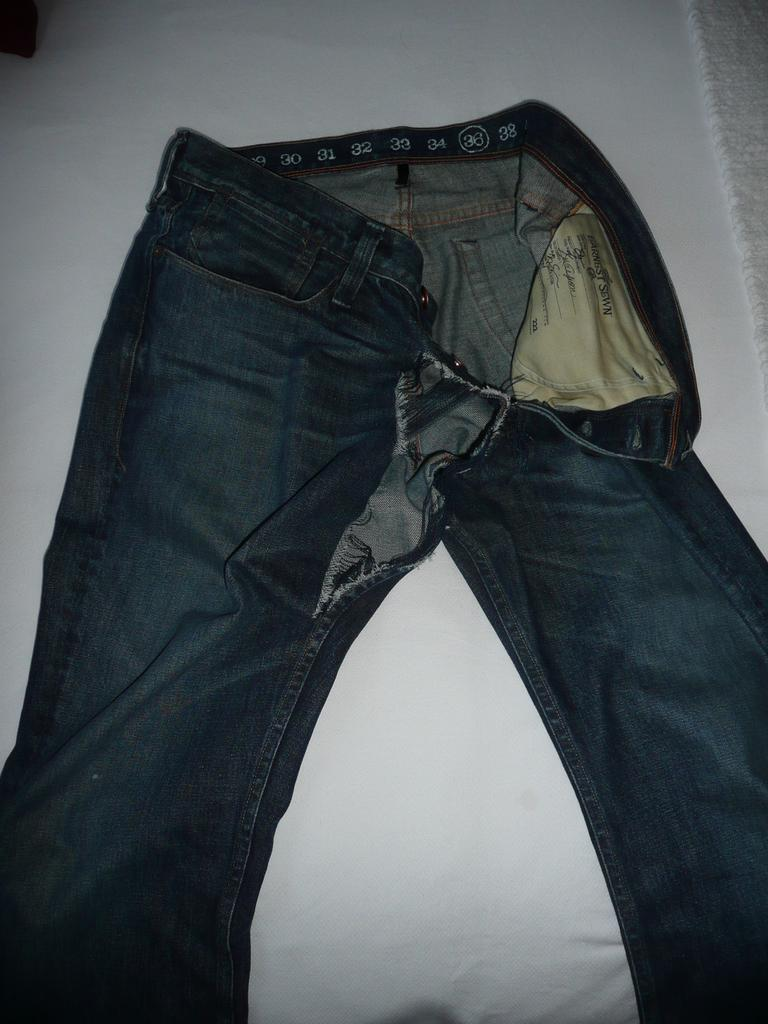What is the color of the surface in the background of the image? The surface in the background of the image is white. What is placed on the white surface? There is a pair of jeans on the white surface. What is the condition of the jeans? The jeans are torn. What type of gun is visible on the jeans in the image? There is no gun present on the jeans in the image. What type of flesh can be seen on the jeans in the image? There is no flesh present on the jeans in the image. 